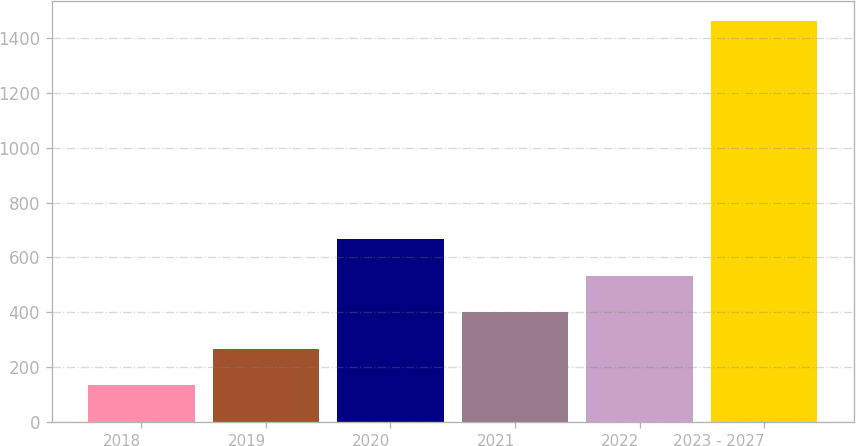<chart> <loc_0><loc_0><loc_500><loc_500><bar_chart><fcel>2018<fcel>2019<fcel>2020<fcel>2021<fcel>2022<fcel>2023 - 2027<nl><fcel>135<fcel>267.7<fcel>665.8<fcel>400.4<fcel>533.1<fcel>1462<nl></chart> 